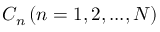Convert formula to latex. <formula><loc_0><loc_0><loc_500><loc_500>{ { C _ { n } } \left ( { n = 1 , 2 , \dots , N } \right ) }</formula> 